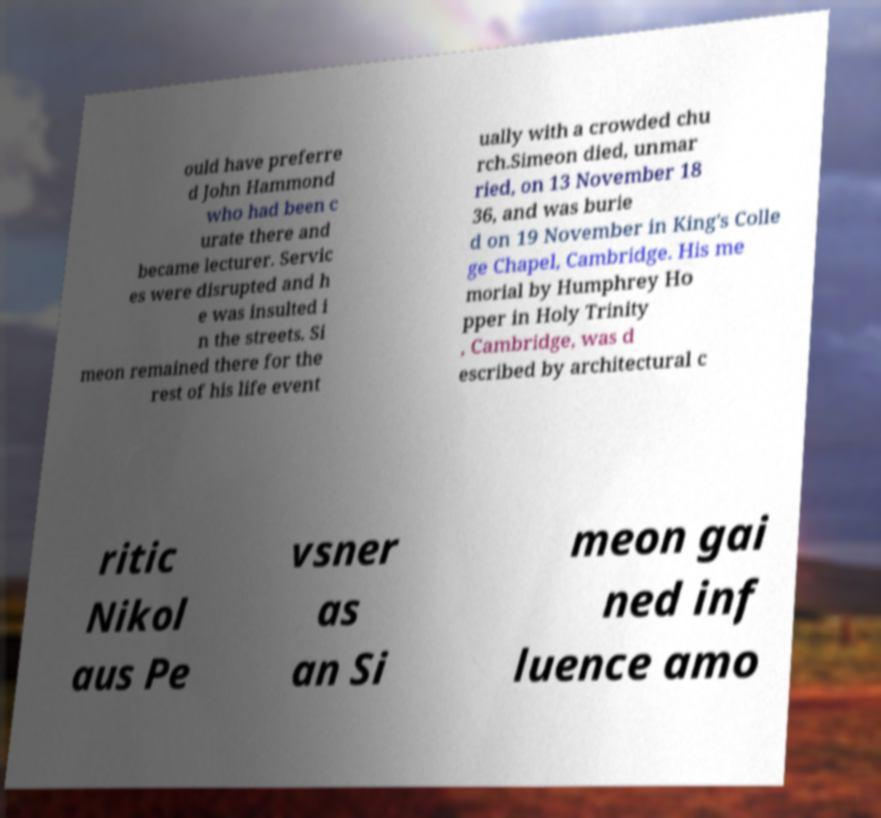Please identify and transcribe the text found in this image. ould have preferre d John Hammond who had been c urate there and became lecturer. Servic es were disrupted and h e was insulted i n the streets. Si meon remained there for the rest of his life event ually with a crowded chu rch.Simeon died, unmar ried, on 13 November 18 36, and was burie d on 19 November in King's Colle ge Chapel, Cambridge. His me morial by Humphrey Ho pper in Holy Trinity , Cambridge, was d escribed by architectural c ritic Nikol aus Pe vsner as an Si meon gai ned inf luence amo 